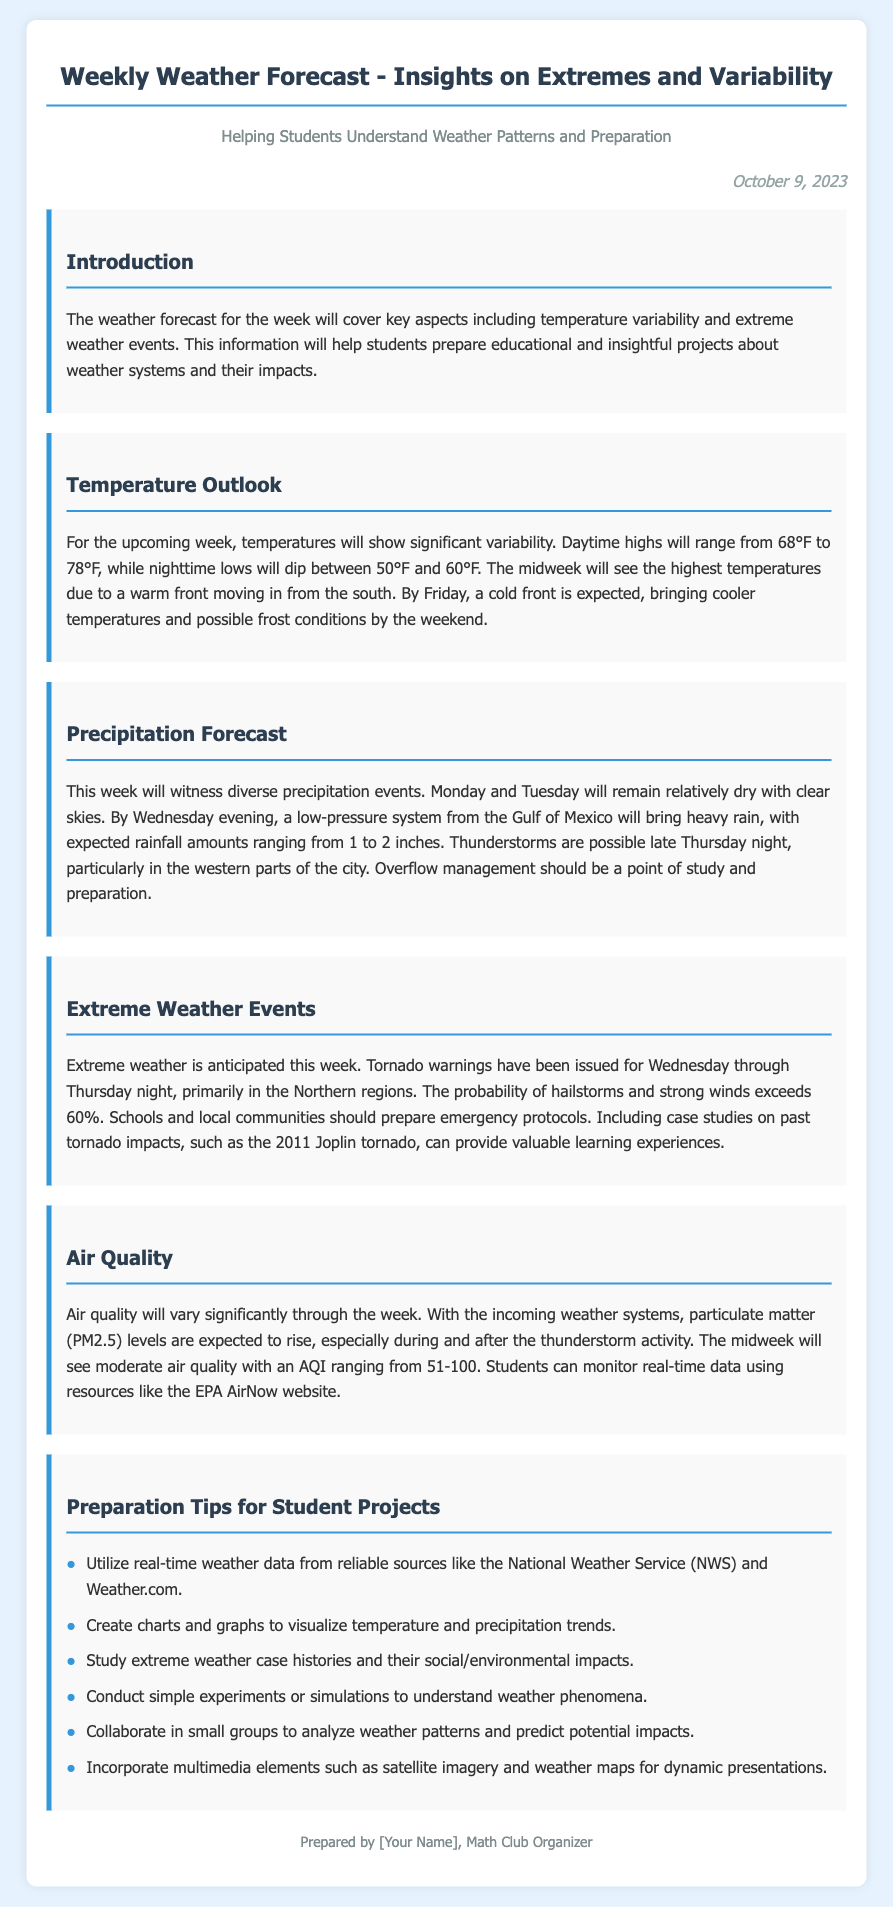What is the date of the weather forecast? The date is specified in the document as October 9, 2023.
Answer: October 9, 2023 What are the expected daytime highs this week? The forecast indicates daytime highs will range from 68°F to 78°F.
Answer: 68°F to 78°F What is the expected rainfall amount for Wednesday evening? The document mentions that the expected rainfall amounts are between 1 to 2 inches.
Answer: 1 to 2 inches What should schools prepare for on Wednesday through Thursday night? The forecast warns of tornado warnings issued for the Northern regions during this time.
Answer: Tornado warnings What is the range of the Air Quality Index (AQI) during the midweek? The AQI is expected to range from 51 to 100 midweek as per the document.
Answer: 51-100 What types of visual aids are suggested for student projects? The document suggests creating charts and graphs to visualize temperature and precipitation trends.
Answer: Charts and graphs Which website is mentioned for monitoring air quality? The document refers to the EPA AirNow website for monitoring purposes.
Answer: EPA AirNow What should students study regarding extreme weather? The document recommends studying extreme weather case histories and their impacts.
Answer: Case histories What might happen by Friday according to the temperature outlook? The forecast indicates that a cold front is expected, bringing cooler temperatures and possible frost conditions.
Answer: Cooler temperatures and frost conditions 